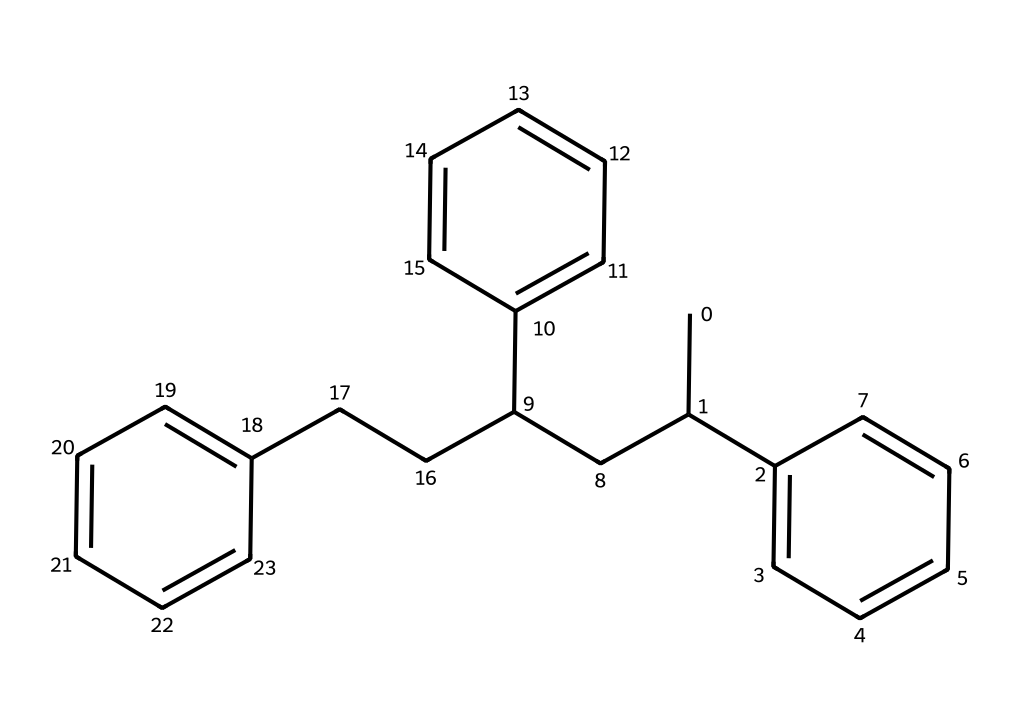What is the main repeating unit in the structure? The main repeating unit is the styrene monomer, which is identified by the phenyl group and the ethylene group connected to it. In this structure, the presence of multiple phenyl rings indicates that it is derived from the polymerization of styrene.
Answer: styrene How many benzene rings are present in the structure? The SMILES representation shows three distinct "C=CC" groups that form benzene rings (each corresponding to a phenyl group), indicating there are three benzene rings in total.
Answer: three What type of polymer is represented by this structure? This structure represents a thermoplastic polymer known for its rigidity and clarity, derived from the polymerization of styrene. Such polymers are often used in laboratory equipment.
Answer: thermoplastic What is the degree of unsaturation in this structure? The degree of unsaturation can be assessed by counting the number of rings and double bonds. Here, examining the structure shows three rings and multiple double bonds indicates a high degree of unsaturation.
Answer: high Which functional groups are likely present in polystyrene? Based on the structure, polystyrene primarily consists of carbon-carbon bonds and phenyl groups, but does not show other functional groups like -OH or -COOH which would indicate different properties.
Answer: none What is the primary application of this polymer in the laboratory? Polystyrene is commonly utilized in lab equipment such as test tubes and Petri dishes due to its clarity and ease of molding.
Answer: laboratory equipment How does the structure influence the physical properties of polystyrene? The presence of the rigid benzene rings in the structure contributes to the strength and stiffness of polystyrene, making it useful in applications requiring durability and clarity.
Answer: rigidity and durability 